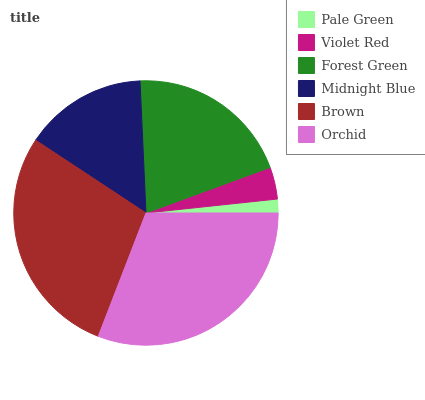Is Pale Green the minimum?
Answer yes or no. Yes. Is Orchid the maximum?
Answer yes or no. Yes. Is Violet Red the minimum?
Answer yes or no. No. Is Violet Red the maximum?
Answer yes or no. No. Is Violet Red greater than Pale Green?
Answer yes or no. Yes. Is Pale Green less than Violet Red?
Answer yes or no. Yes. Is Pale Green greater than Violet Red?
Answer yes or no. No. Is Violet Red less than Pale Green?
Answer yes or no. No. Is Forest Green the high median?
Answer yes or no. Yes. Is Midnight Blue the low median?
Answer yes or no. Yes. Is Brown the high median?
Answer yes or no. No. Is Pale Green the low median?
Answer yes or no. No. 